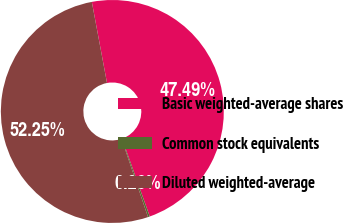<chart> <loc_0><loc_0><loc_500><loc_500><pie_chart><fcel>Basic weighted-average shares<fcel>Common stock equivalents<fcel>Diluted weighted-average<nl><fcel>47.49%<fcel>0.26%<fcel>52.24%<nl></chart> 